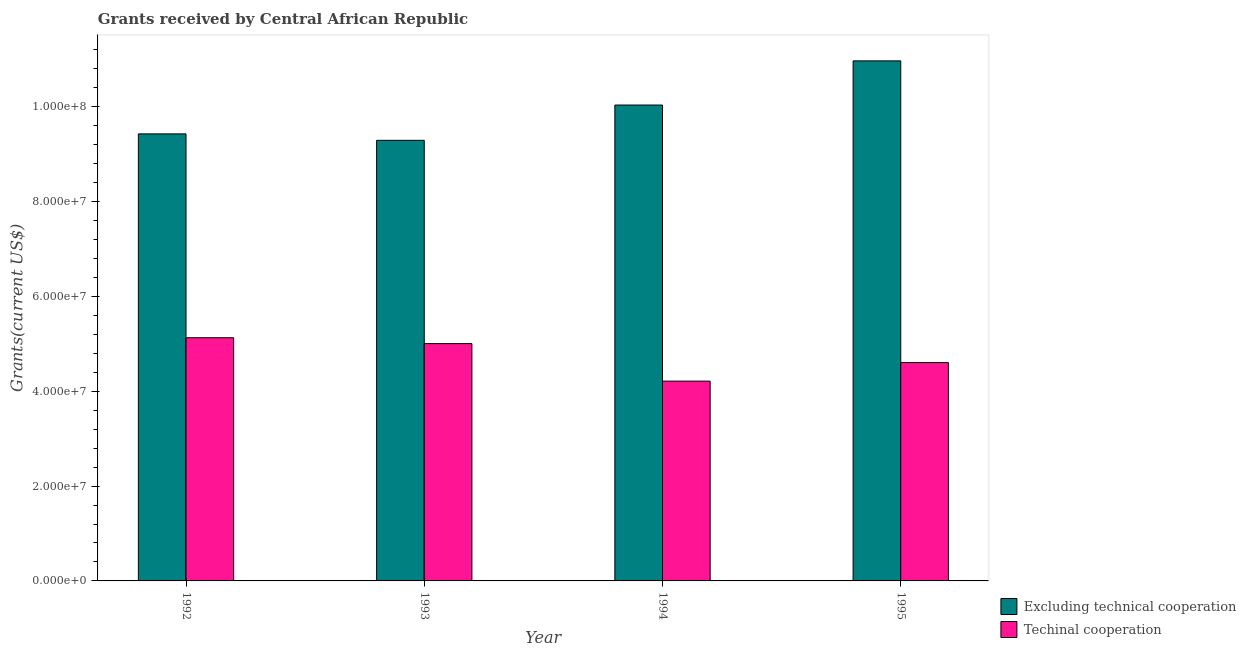Are the number of bars per tick equal to the number of legend labels?
Your response must be concise. Yes. What is the amount of grants received(excluding technical cooperation) in 1992?
Keep it short and to the point. 9.42e+07. Across all years, what is the maximum amount of grants received(including technical cooperation)?
Offer a terse response. 5.13e+07. Across all years, what is the minimum amount of grants received(excluding technical cooperation)?
Make the answer very short. 9.29e+07. In which year was the amount of grants received(excluding technical cooperation) maximum?
Your answer should be very brief. 1995. In which year was the amount of grants received(excluding technical cooperation) minimum?
Give a very brief answer. 1993. What is the total amount of grants received(excluding technical cooperation) in the graph?
Offer a very short reply. 3.97e+08. What is the difference between the amount of grants received(excluding technical cooperation) in 1993 and that in 1994?
Give a very brief answer. -7.44e+06. What is the difference between the amount of grants received(excluding technical cooperation) in 1994 and the amount of grants received(including technical cooperation) in 1993?
Your response must be concise. 7.44e+06. What is the average amount of grants received(excluding technical cooperation) per year?
Provide a succinct answer. 9.93e+07. In how many years, is the amount of grants received(excluding technical cooperation) greater than 56000000 US$?
Make the answer very short. 4. What is the ratio of the amount of grants received(excluding technical cooperation) in 1994 to that in 1995?
Give a very brief answer. 0.92. What is the difference between the highest and the second highest amount of grants received(including technical cooperation)?
Offer a terse response. 1.24e+06. What is the difference between the highest and the lowest amount of grants received(including technical cooperation)?
Offer a terse response. 9.15e+06. In how many years, is the amount of grants received(excluding technical cooperation) greater than the average amount of grants received(excluding technical cooperation) taken over all years?
Your answer should be compact. 2. What does the 2nd bar from the left in 1992 represents?
Provide a succinct answer. Techinal cooperation. What does the 1st bar from the right in 1995 represents?
Offer a terse response. Techinal cooperation. How many legend labels are there?
Your response must be concise. 2. How are the legend labels stacked?
Your response must be concise. Vertical. What is the title of the graph?
Your answer should be very brief. Grants received by Central African Republic. What is the label or title of the Y-axis?
Offer a very short reply. Grants(current US$). What is the Grants(current US$) in Excluding technical cooperation in 1992?
Offer a terse response. 9.42e+07. What is the Grants(current US$) in Techinal cooperation in 1992?
Provide a short and direct response. 5.13e+07. What is the Grants(current US$) in Excluding technical cooperation in 1993?
Offer a very short reply. 9.29e+07. What is the Grants(current US$) of Techinal cooperation in 1993?
Provide a short and direct response. 5.00e+07. What is the Grants(current US$) in Excluding technical cooperation in 1994?
Keep it short and to the point. 1.00e+08. What is the Grants(current US$) of Techinal cooperation in 1994?
Provide a short and direct response. 4.21e+07. What is the Grants(current US$) in Excluding technical cooperation in 1995?
Your response must be concise. 1.10e+08. What is the Grants(current US$) of Techinal cooperation in 1995?
Your answer should be very brief. 4.60e+07. Across all years, what is the maximum Grants(current US$) of Excluding technical cooperation?
Offer a terse response. 1.10e+08. Across all years, what is the maximum Grants(current US$) of Techinal cooperation?
Your response must be concise. 5.13e+07. Across all years, what is the minimum Grants(current US$) in Excluding technical cooperation?
Ensure brevity in your answer.  9.29e+07. Across all years, what is the minimum Grants(current US$) of Techinal cooperation?
Provide a short and direct response. 4.21e+07. What is the total Grants(current US$) of Excluding technical cooperation in the graph?
Keep it short and to the point. 3.97e+08. What is the total Grants(current US$) of Techinal cooperation in the graph?
Keep it short and to the point. 1.89e+08. What is the difference between the Grants(current US$) in Excluding technical cooperation in 1992 and that in 1993?
Provide a succinct answer. 1.36e+06. What is the difference between the Grants(current US$) of Techinal cooperation in 1992 and that in 1993?
Provide a succinct answer. 1.24e+06. What is the difference between the Grants(current US$) of Excluding technical cooperation in 1992 and that in 1994?
Ensure brevity in your answer.  -6.08e+06. What is the difference between the Grants(current US$) in Techinal cooperation in 1992 and that in 1994?
Give a very brief answer. 9.15e+06. What is the difference between the Grants(current US$) in Excluding technical cooperation in 1992 and that in 1995?
Provide a succinct answer. -1.54e+07. What is the difference between the Grants(current US$) in Techinal cooperation in 1992 and that in 1995?
Your answer should be very brief. 5.24e+06. What is the difference between the Grants(current US$) of Excluding technical cooperation in 1993 and that in 1994?
Provide a short and direct response. -7.44e+06. What is the difference between the Grants(current US$) in Techinal cooperation in 1993 and that in 1994?
Make the answer very short. 7.91e+06. What is the difference between the Grants(current US$) in Excluding technical cooperation in 1993 and that in 1995?
Your answer should be compact. -1.68e+07. What is the difference between the Grants(current US$) of Excluding technical cooperation in 1994 and that in 1995?
Provide a succinct answer. -9.31e+06. What is the difference between the Grants(current US$) in Techinal cooperation in 1994 and that in 1995?
Keep it short and to the point. -3.91e+06. What is the difference between the Grants(current US$) in Excluding technical cooperation in 1992 and the Grants(current US$) in Techinal cooperation in 1993?
Your answer should be compact. 4.42e+07. What is the difference between the Grants(current US$) in Excluding technical cooperation in 1992 and the Grants(current US$) in Techinal cooperation in 1994?
Offer a very short reply. 5.21e+07. What is the difference between the Grants(current US$) of Excluding technical cooperation in 1992 and the Grants(current US$) of Techinal cooperation in 1995?
Your answer should be very brief. 4.82e+07. What is the difference between the Grants(current US$) in Excluding technical cooperation in 1993 and the Grants(current US$) in Techinal cooperation in 1994?
Ensure brevity in your answer.  5.08e+07. What is the difference between the Grants(current US$) of Excluding technical cooperation in 1993 and the Grants(current US$) of Techinal cooperation in 1995?
Make the answer very short. 4.69e+07. What is the difference between the Grants(current US$) of Excluding technical cooperation in 1994 and the Grants(current US$) of Techinal cooperation in 1995?
Your response must be concise. 5.43e+07. What is the average Grants(current US$) in Excluding technical cooperation per year?
Your response must be concise. 9.93e+07. What is the average Grants(current US$) of Techinal cooperation per year?
Make the answer very short. 4.74e+07. In the year 1992, what is the difference between the Grants(current US$) in Excluding technical cooperation and Grants(current US$) in Techinal cooperation?
Ensure brevity in your answer.  4.30e+07. In the year 1993, what is the difference between the Grants(current US$) of Excluding technical cooperation and Grants(current US$) of Techinal cooperation?
Ensure brevity in your answer.  4.29e+07. In the year 1994, what is the difference between the Grants(current US$) of Excluding technical cooperation and Grants(current US$) of Techinal cooperation?
Keep it short and to the point. 5.82e+07. In the year 1995, what is the difference between the Grants(current US$) of Excluding technical cooperation and Grants(current US$) of Techinal cooperation?
Give a very brief answer. 6.36e+07. What is the ratio of the Grants(current US$) in Excluding technical cooperation in 1992 to that in 1993?
Provide a short and direct response. 1.01. What is the ratio of the Grants(current US$) in Techinal cooperation in 1992 to that in 1993?
Offer a terse response. 1.02. What is the ratio of the Grants(current US$) of Excluding technical cooperation in 1992 to that in 1994?
Ensure brevity in your answer.  0.94. What is the ratio of the Grants(current US$) in Techinal cooperation in 1992 to that in 1994?
Provide a succinct answer. 1.22. What is the ratio of the Grants(current US$) of Excluding technical cooperation in 1992 to that in 1995?
Your answer should be compact. 0.86. What is the ratio of the Grants(current US$) in Techinal cooperation in 1992 to that in 1995?
Your answer should be compact. 1.11. What is the ratio of the Grants(current US$) of Excluding technical cooperation in 1993 to that in 1994?
Make the answer very short. 0.93. What is the ratio of the Grants(current US$) of Techinal cooperation in 1993 to that in 1994?
Give a very brief answer. 1.19. What is the ratio of the Grants(current US$) in Excluding technical cooperation in 1993 to that in 1995?
Offer a very short reply. 0.85. What is the ratio of the Grants(current US$) in Techinal cooperation in 1993 to that in 1995?
Ensure brevity in your answer.  1.09. What is the ratio of the Grants(current US$) in Excluding technical cooperation in 1994 to that in 1995?
Keep it short and to the point. 0.92. What is the ratio of the Grants(current US$) in Techinal cooperation in 1994 to that in 1995?
Give a very brief answer. 0.92. What is the difference between the highest and the second highest Grants(current US$) of Excluding technical cooperation?
Your answer should be very brief. 9.31e+06. What is the difference between the highest and the second highest Grants(current US$) in Techinal cooperation?
Your answer should be compact. 1.24e+06. What is the difference between the highest and the lowest Grants(current US$) of Excluding technical cooperation?
Your response must be concise. 1.68e+07. What is the difference between the highest and the lowest Grants(current US$) of Techinal cooperation?
Make the answer very short. 9.15e+06. 